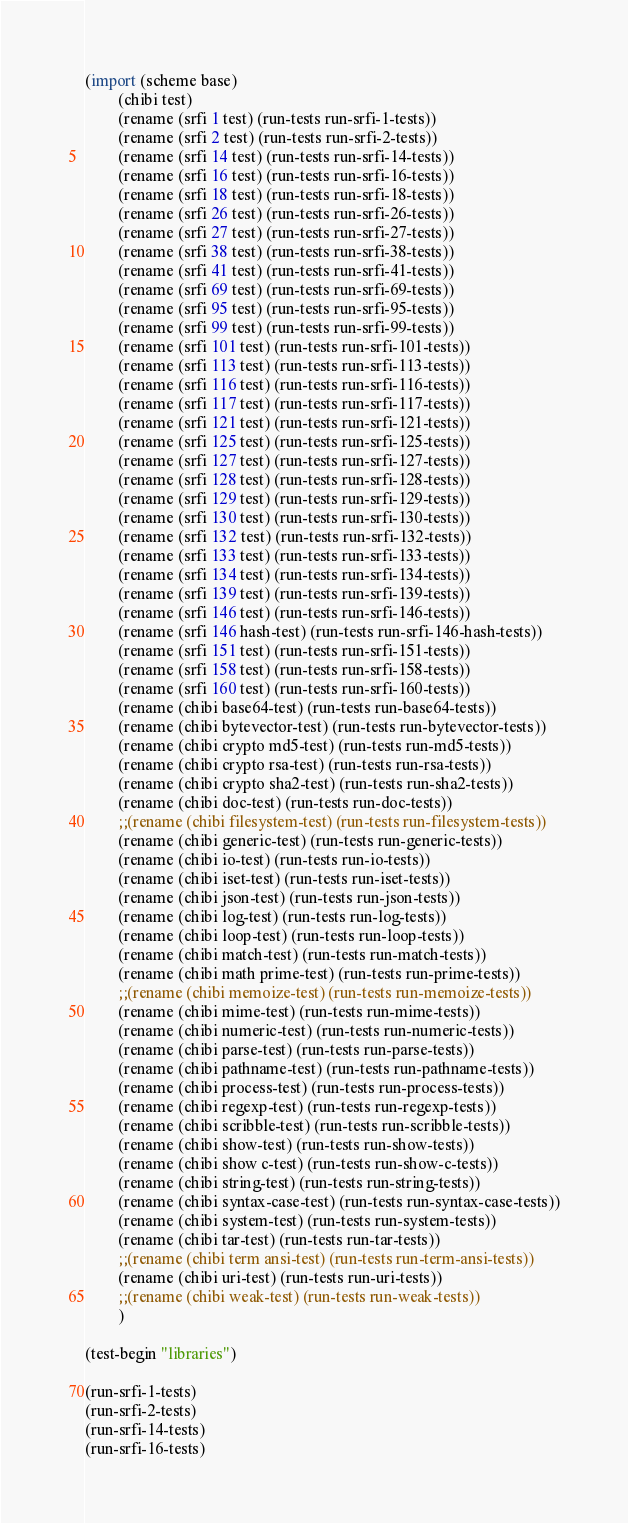Convert code to text. <code><loc_0><loc_0><loc_500><loc_500><_Scheme_>
(import (scheme base)
        (chibi test)
        (rename (srfi 1 test) (run-tests run-srfi-1-tests))
        (rename (srfi 2 test) (run-tests run-srfi-2-tests))
        (rename (srfi 14 test) (run-tests run-srfi-14-tests))
        (rename (srfi 16 test) (run-tests run-srfi-16-tests))
        (rename (srfi 18 test) (run-tests run-srfi-18-tests))
        (rename (srfi 26 test) (run-tests run-srfi-26-tests))
        (rename (srfi 27 test) (run-tests run-srfi-27-tests))
        (rename (srfi 38 test) (run-tests run-srfi-38-tests))
        (rename (srfi 41 test) (run-tests run-srfi-41-tests))
        (rename (srfi 69 test) (run-tests run-srfi-69-tests))
        (rename (srfi 95 test) (run-tests run-srfi-95-tests))
        (rename (srfi 99 test) (run-tests run-srfi-99-tests))
        (rename (srfi 101 test) (run-tests run-srfi-101-tests))
        (rename (srfi 113 test) (run-tests run-srfi-113-tests))
        (rename (srfi 116 test) (run-tests run-srfi-116-tests))
        (rename (srfi 117 test) (run-tests run-srfi-117-tests))
        (rename (srfi 121 test) (run-tests run-srfi-121-tests))
        (rename (srfi 125 test) (run-tests run-srfi-125-tests))
        (rename (srfi 127 test) (run-tests run-srfi-127-tests))
        (rename (srfi 128 test) (run-tests run-srfi-128-tests))
        (rename (srfi 129 test) (run-tests run-srfi-129-tests))
        (rename (srfi 130 test) (run-tests run-srfi-130-tests))
        (rename (srfi 132 test) (run-tests run-srfi-132-tests))
        (rename (srfi 133 test) (run-tests run-srfi-133-tests))
        (rename (srfi 134 test) (run-tests run-srfi-134-tests))
        (rename (srfi 139 test) (run-tests run-srfi-139-tests))
        (rename (srfi 146 test) (run-tests run-srfi-146-tests))
        (rename (srfi 146 hash-test) (run-tests run-srfi-146-hash-tests))
        (rename (srfi 151 test) (run-tests run-srfi-151-tests))
        (rename (srfi 158 test) (run-tests run-srfi-158-tests))
        (rename (srfi 160 test) (run-tests run-srfi-160-tests))
        (rename (chibi base64-test) (run-tests run-base64-tests))
        (rename (chibi bytevector-test) (run-tests run-bytevector-tests))
        (rename (chibi crypto md5-test) (run-tests run-md5-tests))
        (rename (chibi crypto rsa-test) (run-tests run-rsa-tests))
        (rename (chibi crypto sha2-test) (run-tests run-sha2-tests))
        (rename (chibi doc-test) (run-tests run-doc-tests))
        ;;(rename (chibi filesystem-test) (run-tests run-filesystem-tests))
        (rename (chibi generic-test) (run-tests run-generic-tests))
        (rename (chibi io-test) (run-tests run-io-tests))
        (rename (chibi iset-test) (run-tests run-iset-tests))
        (rename (chibi json-test) (run-tests run-json-tests))
        (rename (chibi log-test) (run-tests run-log-tests))
        (rename (chibi loop-test) (run-tests run-loop-tests))
        (rename (chibi match-test) (run-tests run-match-tests))
        (rename (chibi math prime-test) (run-tests run-prime-tests))
        ;;(rename (chibi memoize-test) (run-tests run-memoize-tests))
        (rename (chibi mime-test) (run-tests run-mime-tests))
        (rename (chibi numeric-test) (run-tests run-numeric-tests))
        (rename (chibi parse-test) (run-tests run-parse-tests))
        (rename (chibi pathname-test) (run-tests run-pathname-tests))
        (rename (chibi process-test) (run-tests run-process-tests))
        (rename (chibi regexp-test) (run-tests run-regexp-tests))
        (rename (chibi scribble-test) (run-tests run-scribble-tests))
        (rename (chibi show-test) (run-tests run-show-tests))
        (rename (chibi show c-test) (run-tests run-show-c-tests))
        (rename (chibi string-test) (run-tests run-string-tests))
        (rename (chibi syntax-case-test) (run-tests run-syntax-case-tests))
        (rename (chibi system-test) (run-tests run-system-tests))
        (rename (chibi tar-test) (run-tests run-tar-tests))
        ;;(rename (chibi term ansi-test) (run-tests run-term-ansi-tests))
        (rename (chibi uri-test) (run-tests run-uri-tests))
        ;;(rename (chibi weak-test) (run-tests run-weak-tests))
        )

(test-begin "libraries")

(run-srfi-1-tests)
(run-srfi-2-tests)
(run-srfi-14-tests)
(run-srfi-16-tests)</code> 